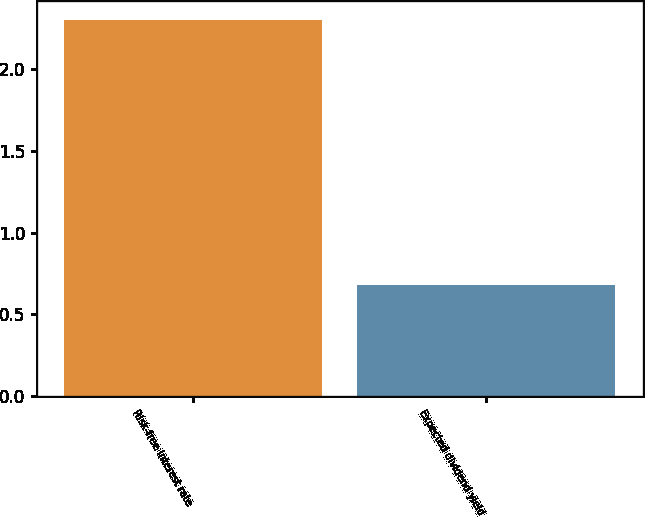Convert chart to OTSL. <chart><loc_0><loc_0><loc_500><loc_500><bar_chart><fcel>Risk-free interest rate<fcel>Expected dividend yield<nl><fcel>2.3<fcel>0.68<nl></chart> 